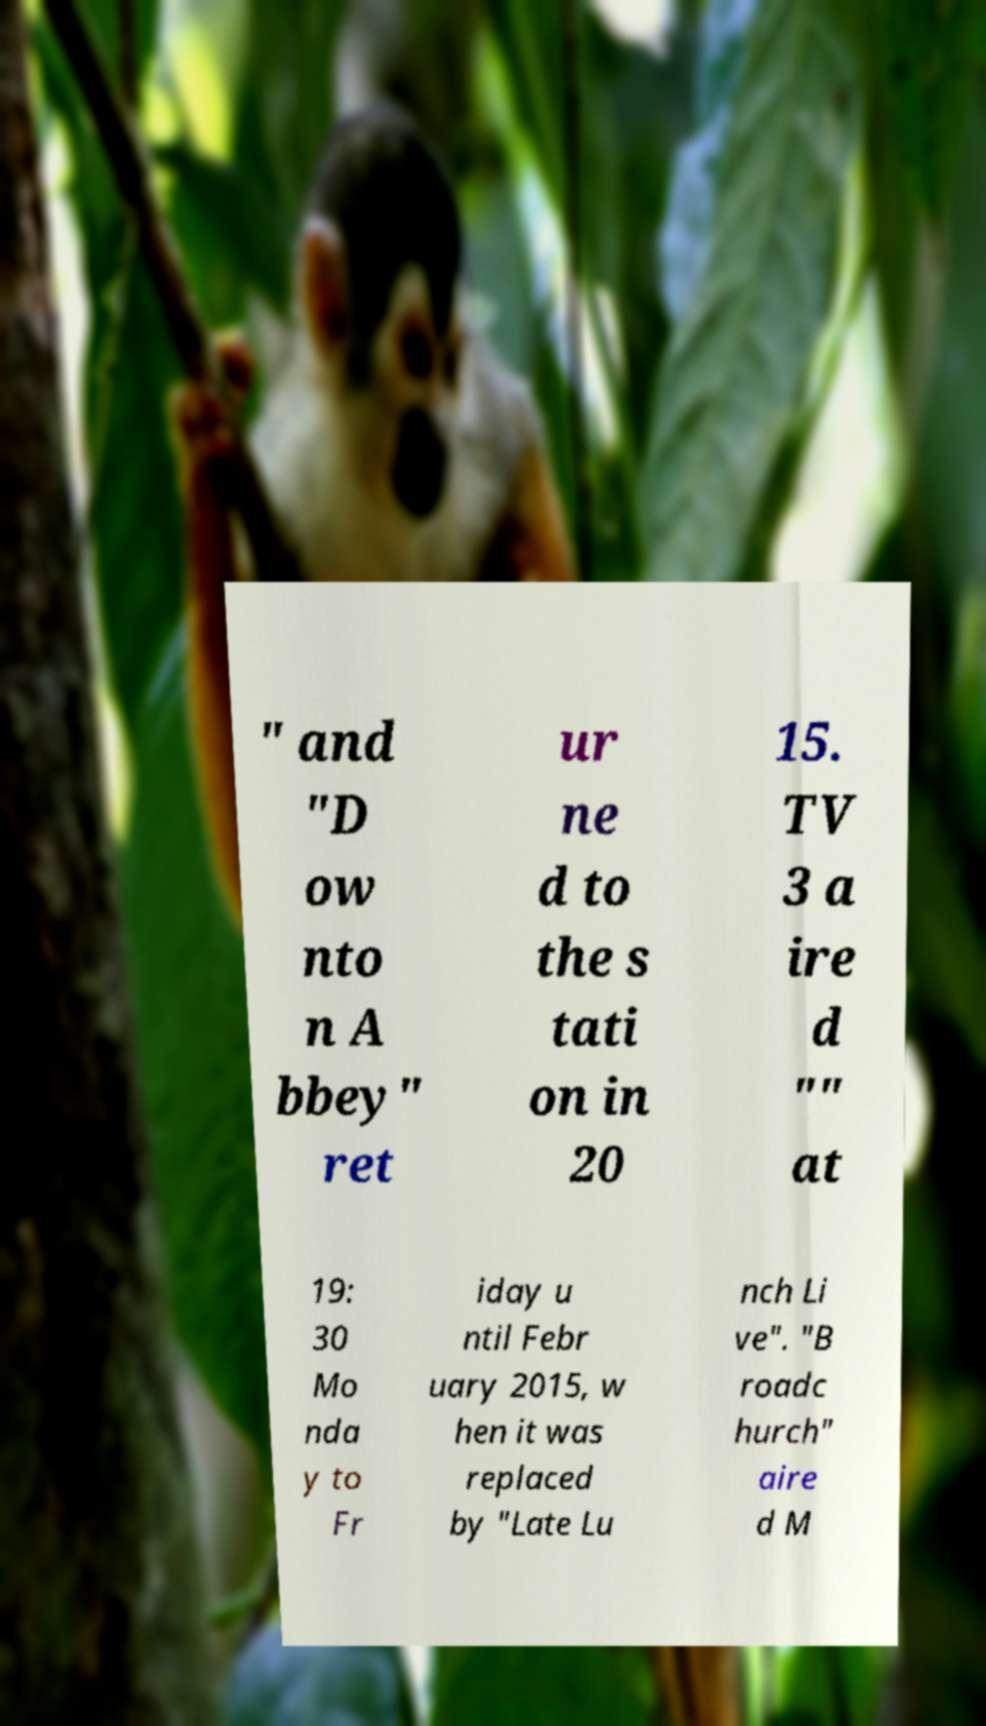Please read and relay the text visible in this image. What does it say? " and "D ow nto n A bbey" ret ur ne d to the s tati on in 20 15. TV 3 a ire d "" at 19: 30 Mo nda y to Fr iday u ntil Febr uary 2015, w hen it was replaced by "Late Lu nch Li ve". "B roadc hurch" aire d M 